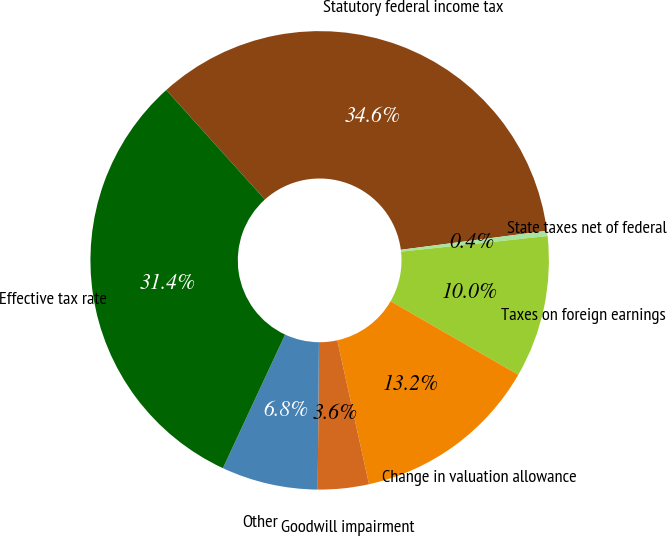<chart> <loc_0><loc_0><loc_500><loc_500><pie_chart><fcel>Statutory federal income tax<fcel>State taxes net of federal<fcel>Taxes on foreign earnings<fcel>Change in valuation allowance<fcel>Goodwill impairment<fcel>Other<fcel>Effective tax rate<nl><fcel>34.61%<fcel>0.37%<fcel>10.01%<fcel>13.23%<fcel>3.59%<fcel>6.8%<fcel>31.4%<nl></chart> 